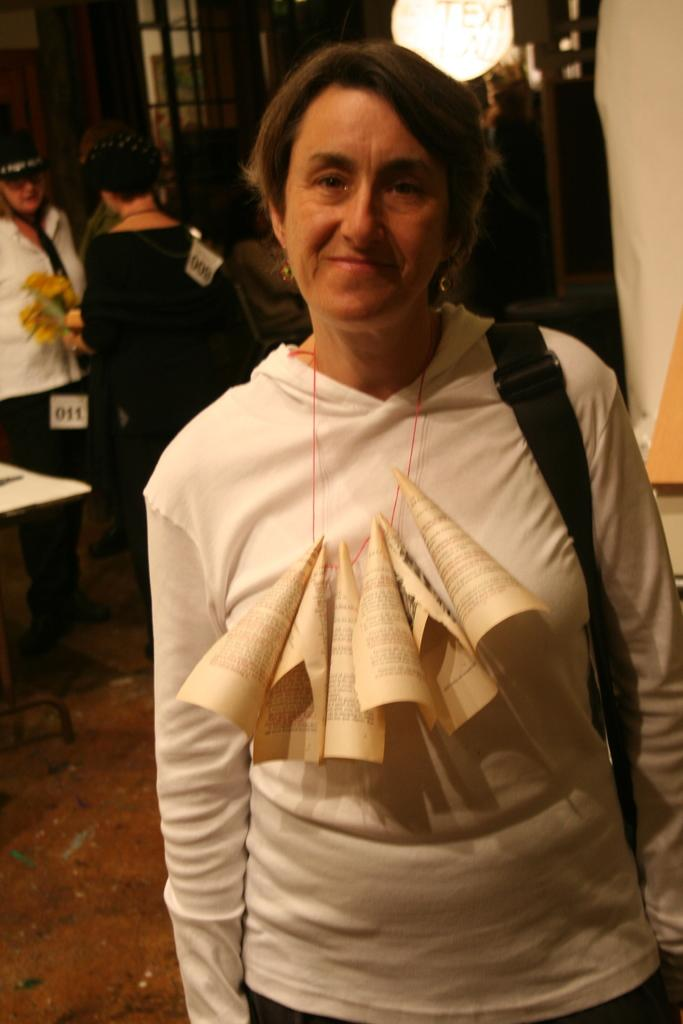What is the woman in the image wearing? The woman is wearing a white dress in the image. What is the woman holding in the image? The woman is holding a bag in the image. Can you describe the woman's attire further? The woman is wearing diapers tied to a rope. What can be seen in the background of the image? There are people in the background of the image. What type of bun is the woman eating in the image? There is no bun present in the image. How does the woman push the balloon in the image? There is no balloon present in the image. 